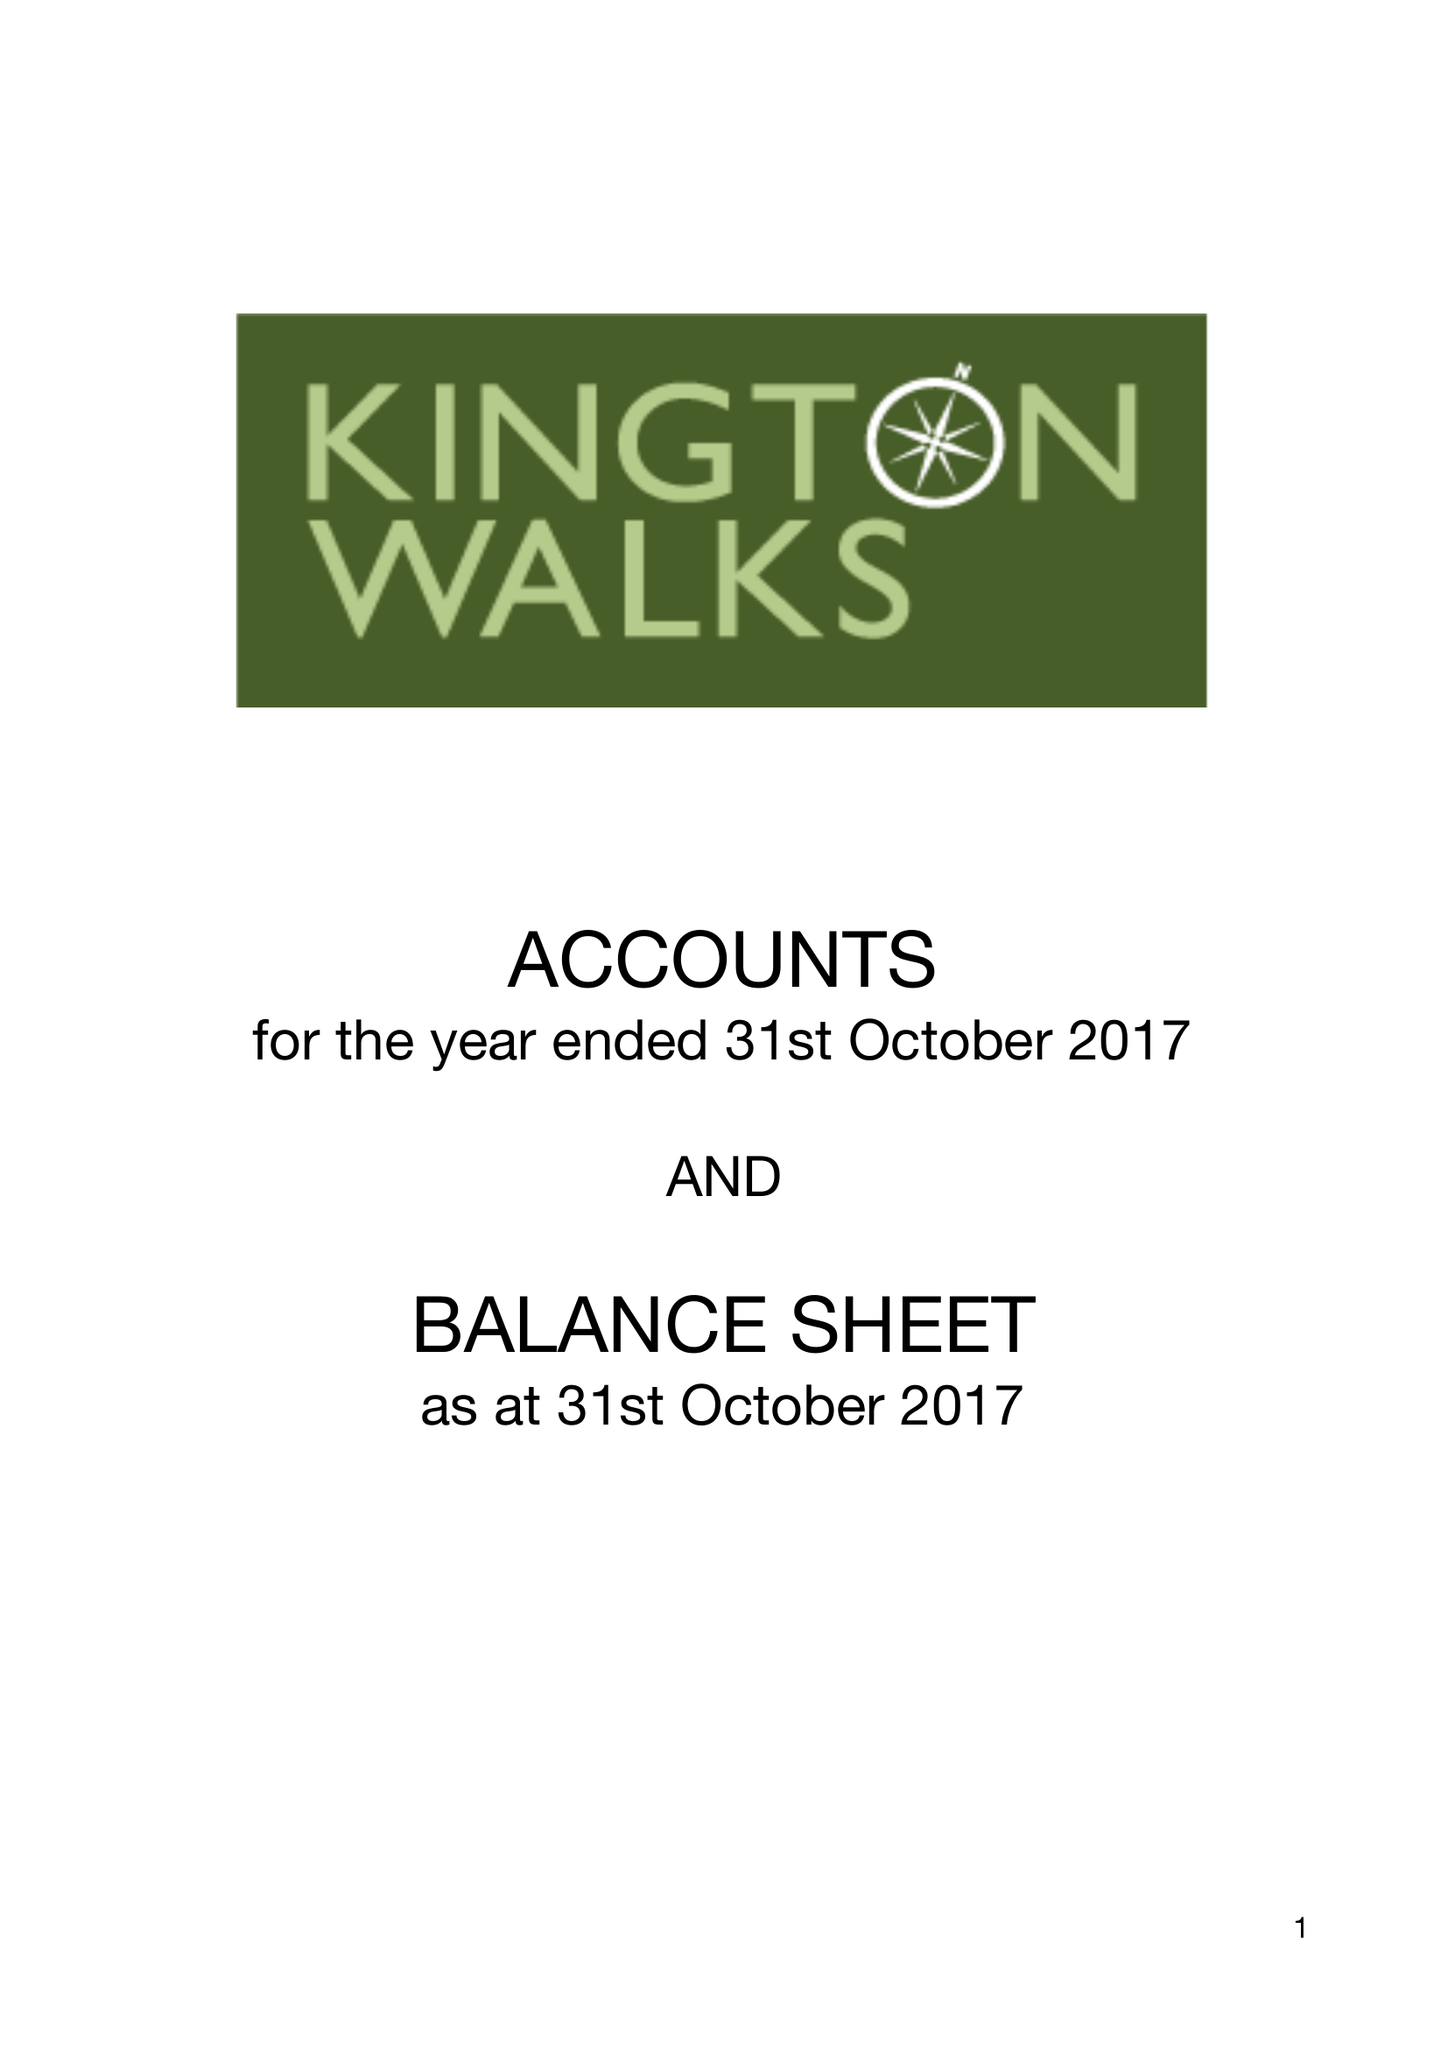What is the value for the income_annually_in_british_pounds?
Answer the question using a single word or phrase. 8551.00 